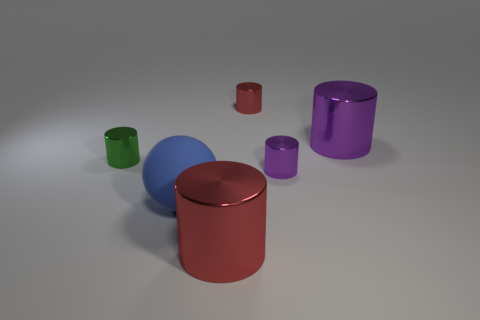Do the thing that is on the left side of the blue matte thing and the small purple cylinder have the same size?
Give a very brief answer. Yes. How many things are to the right of the green metal thing and behind the big matte object?
Offer a very short reply. 3. There is a purple metal cylinder to the left of the large metal object behind the large red metallic cylinder; what size is it?
Your answer should be very brief. Small. Is the number of large purple shiny things that are on the left side of the green thing less than the number of big matte balls that are to the left of the tiny red metal thing?
Make the answer very short. Yes. Does the tiny shiny object that is on the right side of the small red thing have the same color as the thing that is to the right of the tiny purple object?
Provide a short and direct response. Yes. There is a big thing that is both behind the large red object and in front of the large purple shiny cylinder; what material is it?
Keep it short and to the point. Rubber. Are there any small green metal balls?
Your response must be concise. No. What is the shape of the big purple thing that is the same material as the green object?
Provide a succinct answer. Cylinder. Is the shape of the tiny purple object the same as the small object behind the big purple cylinder?
Provide a succinct answer. Yes. What material is the blue ball left of the purple object that is in front of the green object?
Make the answer very short. Rubber. 